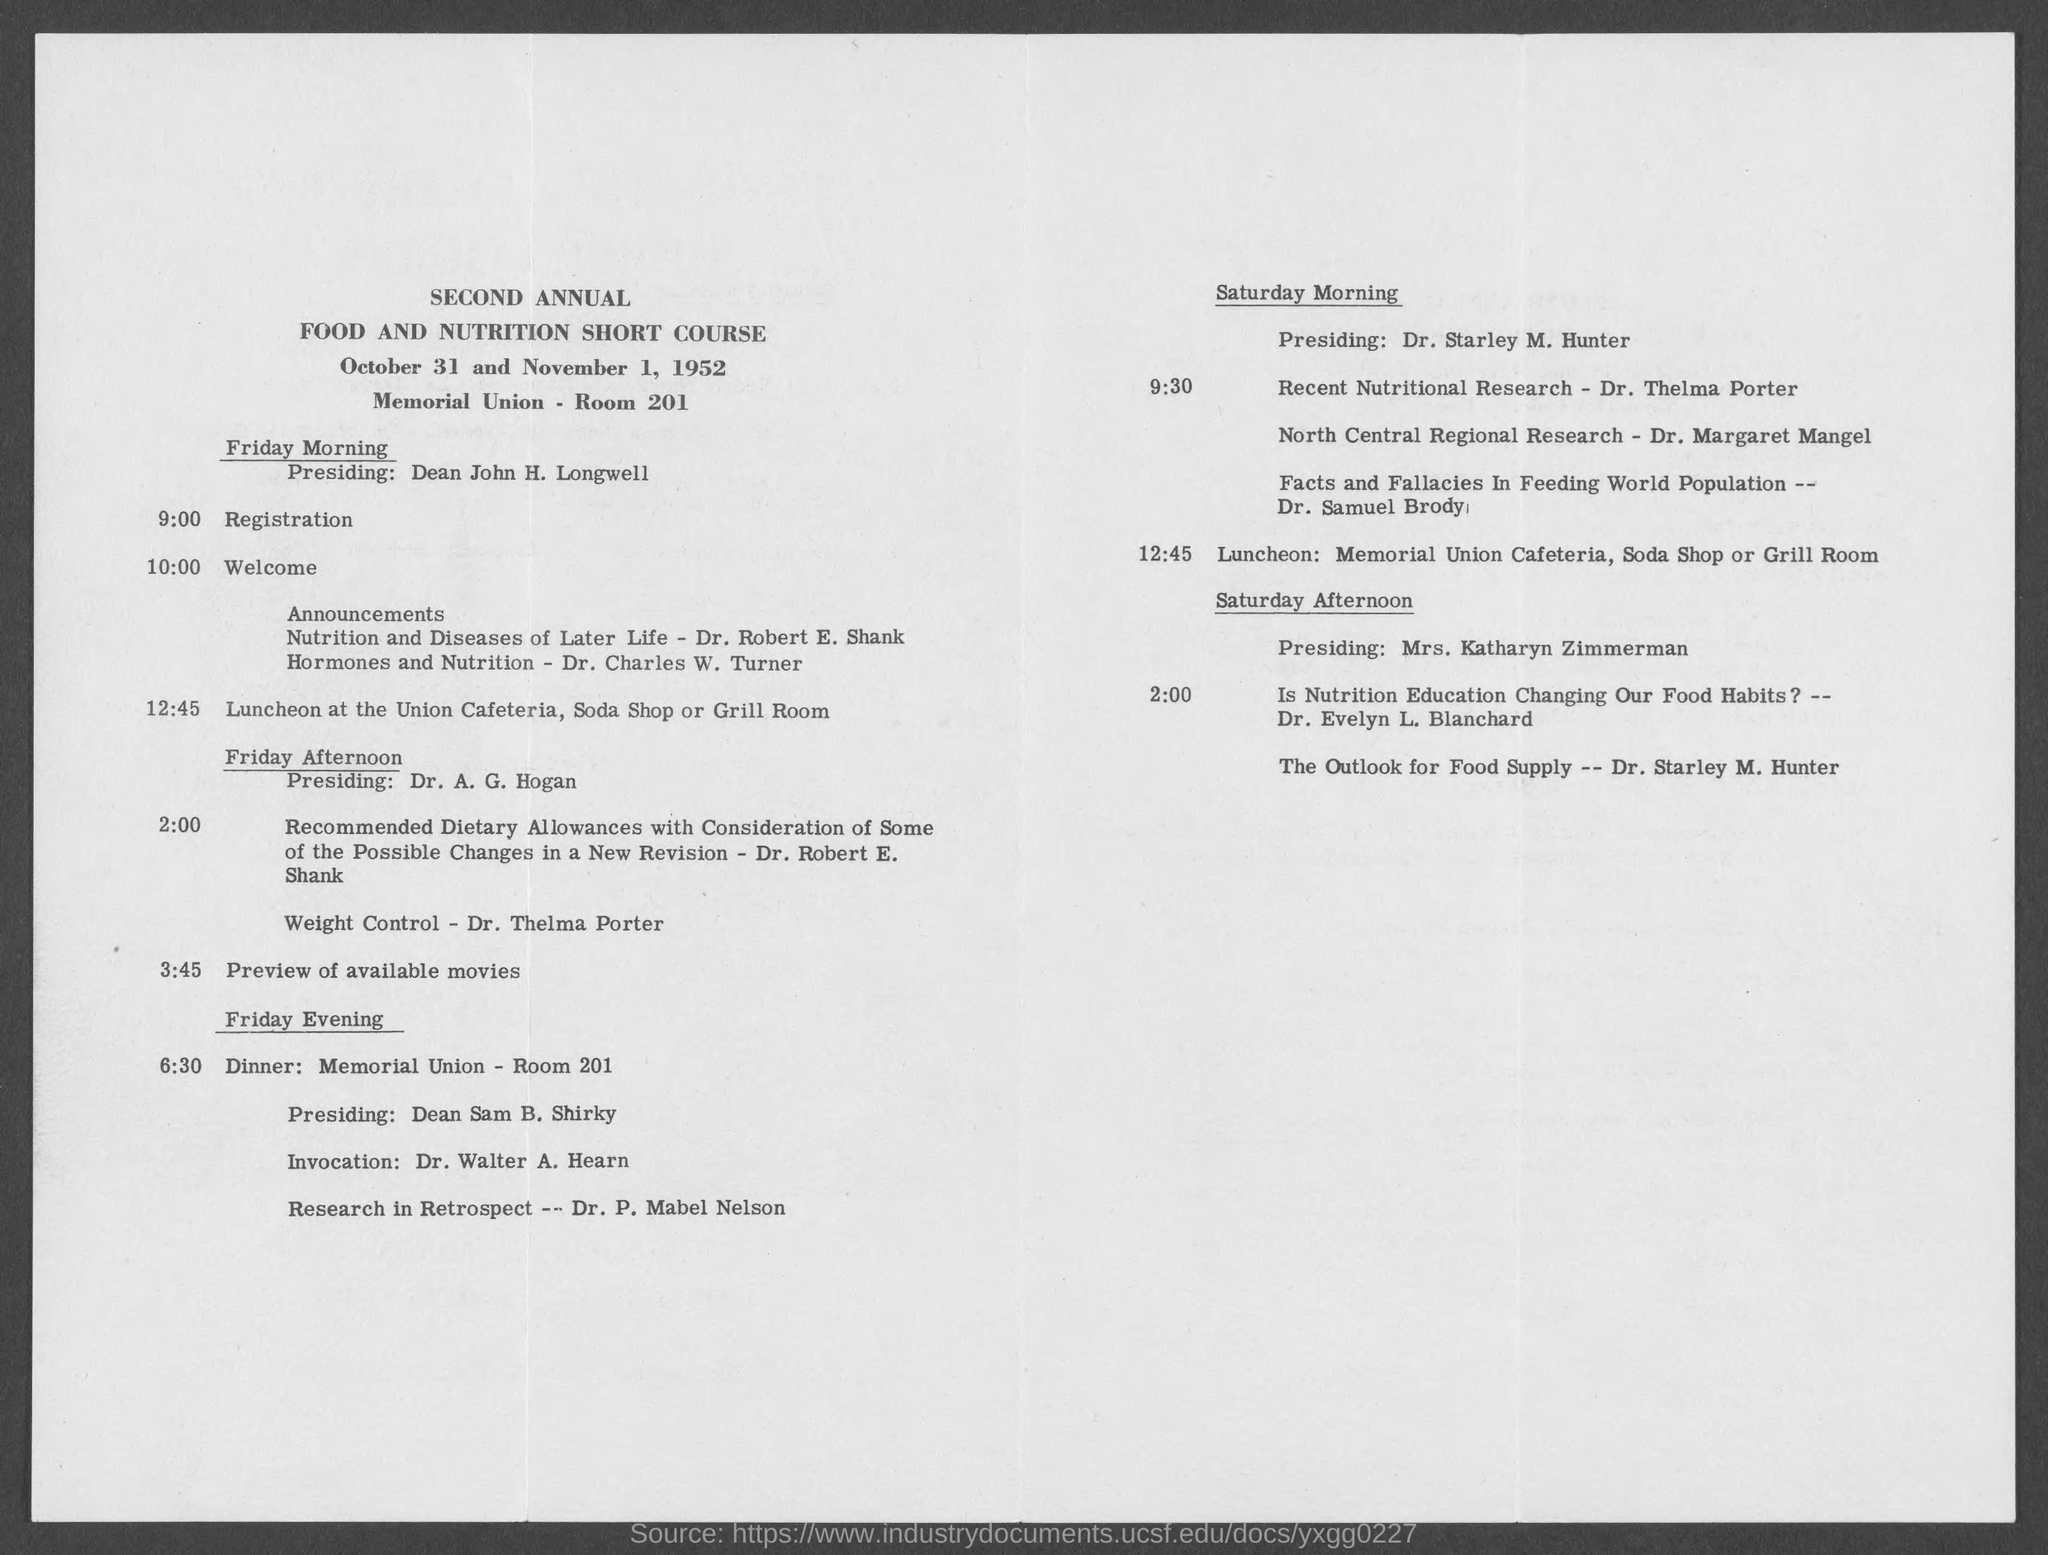What is the duration of Short Course?
Provide a short and direct response. October 31 and November 1, 1952. What is the course?
Ensure brevity in your answer.  SECOND ANNUAL FOOD AND NUTRITION SHORT COURSE. Who was presiding  friday morning?
Ensure brevity in your answer.  Dean John H. Longwell. Who discussed about Hormones and Nutrition?
Provide a succinct answer. Dr. Charles W. Turner. Who discussed Facts and Fallacies In Feeding World Population?
Provide a short and direct response. Dr. Samuel Brody. 